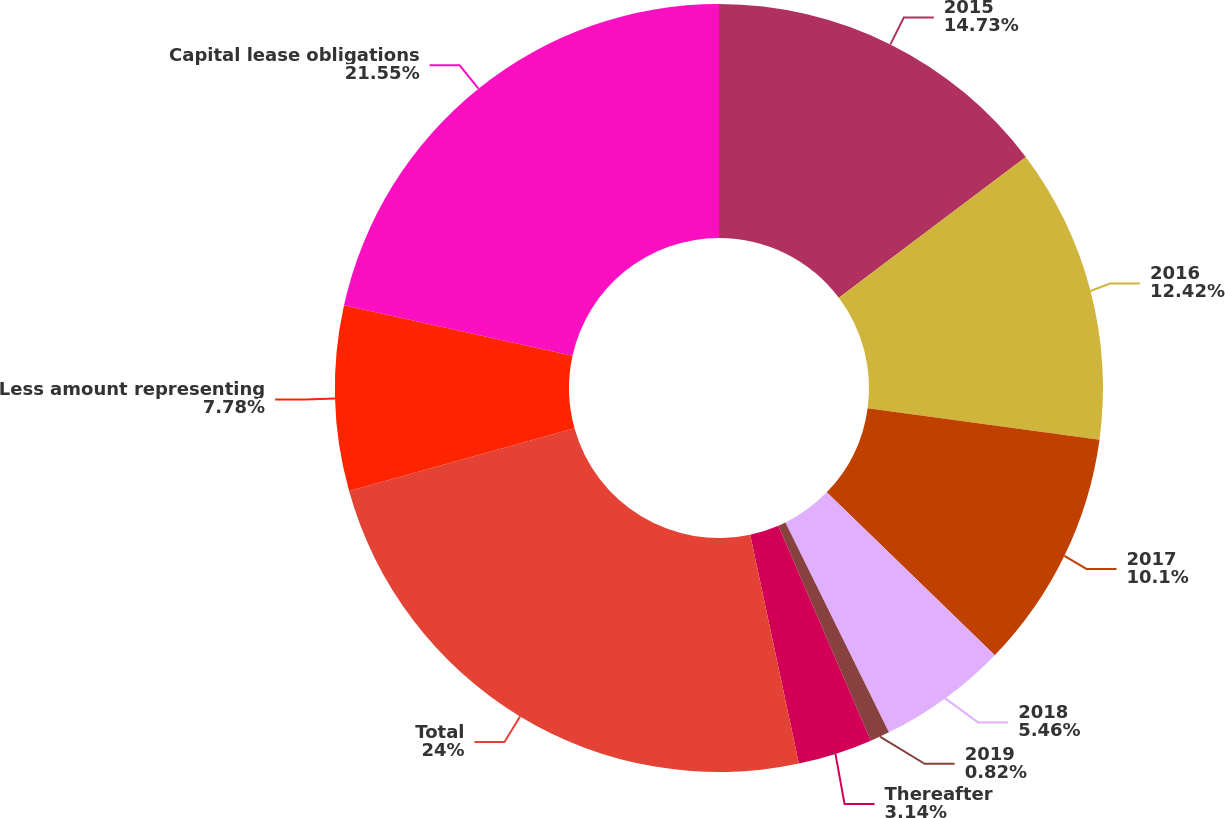<chart> <loc_0><loc_0><loc_500><loc_500><pie_chart><fcel>2015<fcel>2016<fcel>2017<fcel>2018<fcel>2019<fcel>Thereafter<fcel>Total<fcel>Less amount representing<fcel>Capital lease obligations<nl><fcel>14.73%<fcel>12.42%<fcel>10.1%<fcel>5.46%<fcel>0.82%<fcel>3.14%<fcel>24.01%<fcel>7.78%<fcel>21.55%<nl></chart> 